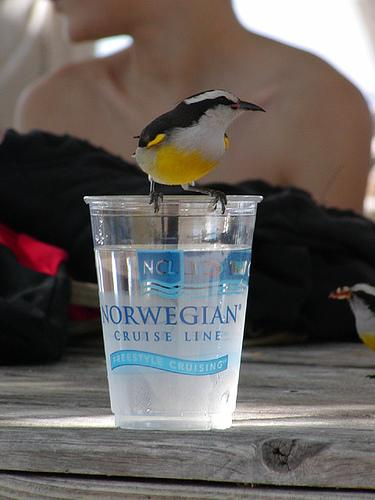What type of vehicle is this cup from? cruise ship 